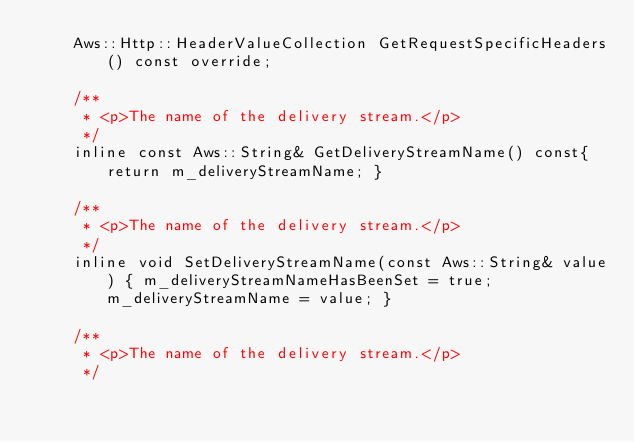<code> <loc_0><loc_0><loc_500><loc_500><_C_>    Aws::Http::HeaderValueCollection GetRequestSpecificHeaders() const override;

    /**
     * <p>The name of the delivery stream.</p>
     */
    inline const Aws::String& GetDeliveryStreamName() const{ return m_deliveryStreamName; }

    /**
     * <p>The name of the delivery stream.</p>
     */
    inline void SetDeliveryStreamName(const Aws::String& value) { m_deliveryStreamNameHasBeenSet = true; m_deliveryStreamName = value; }

    /**
     * <p>The name of the delivery stream.</p>
     */</code> 